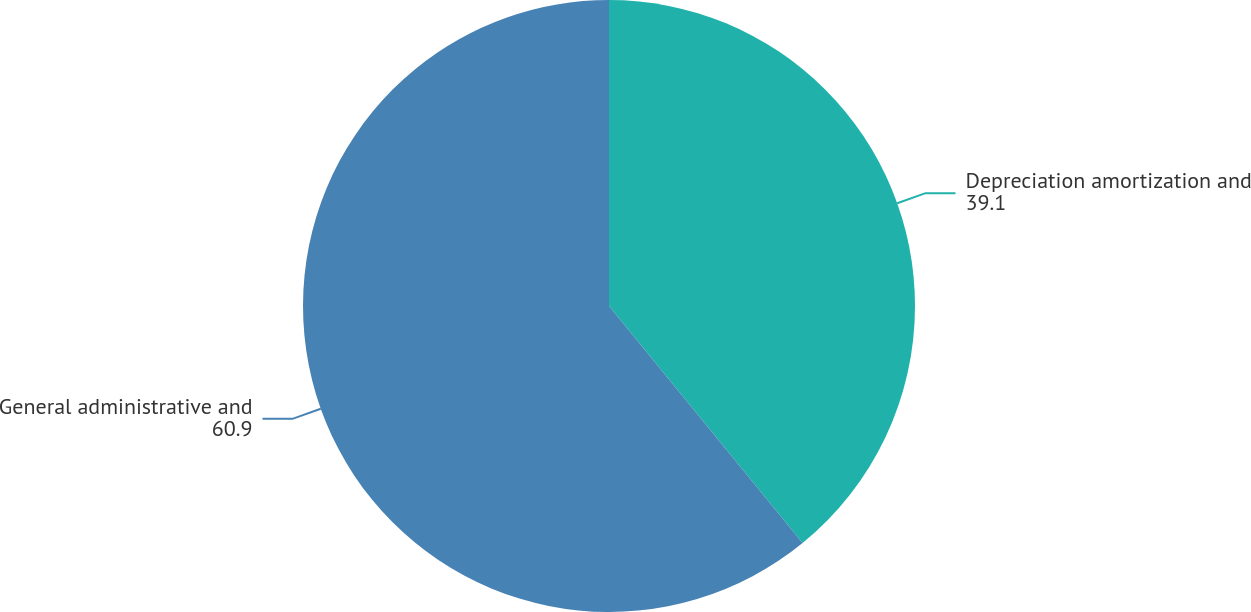Convert chart. <chart><loc_0><loc_0><loc_500><loc_500><pie_chart><fcel>Depreciation amortization and<fcel>General administrative and<nl><fcel>39.1%<fcel>60.9%<nl></chart> 